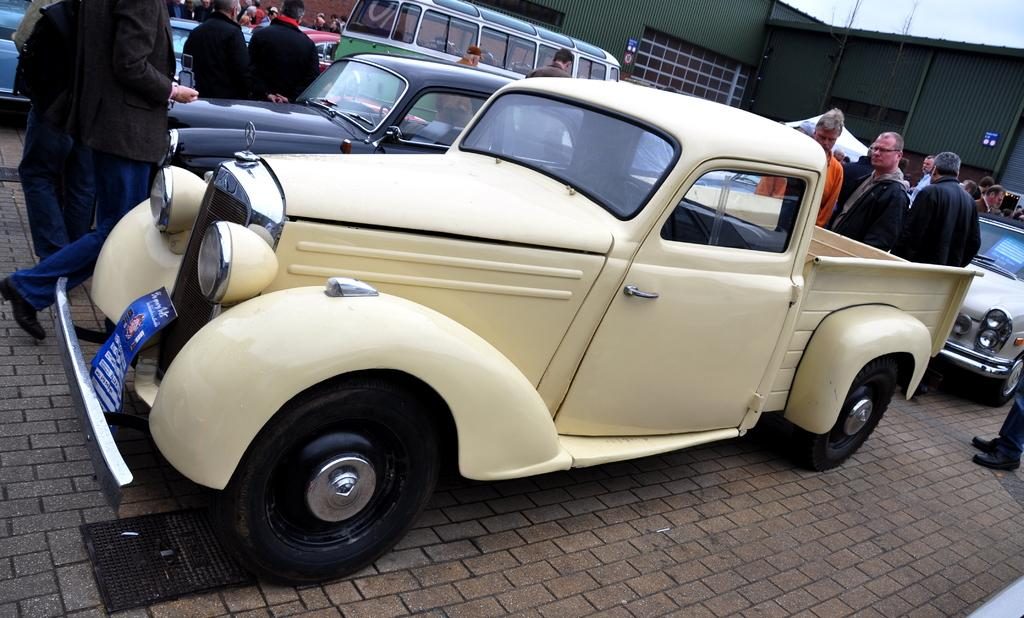What types of objects are present in the image? There are vehicles and persons in the image. Can you describe the setting of the image? In the background of the image, there is a shed and the sky is visible. How many vehicles are visible in the image? The number of vehicles is not specified, but there are vehicles present. How many pairs of underwear are hanging from the shed in the image? There is no mention of underwear or any clothing items hanging from the shed in the image. 